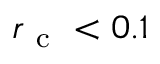Convert formula to latex. <formula><loc_0><loc_0><loc_500><loc_500>r _ { c } < 0 . 1</formula> 